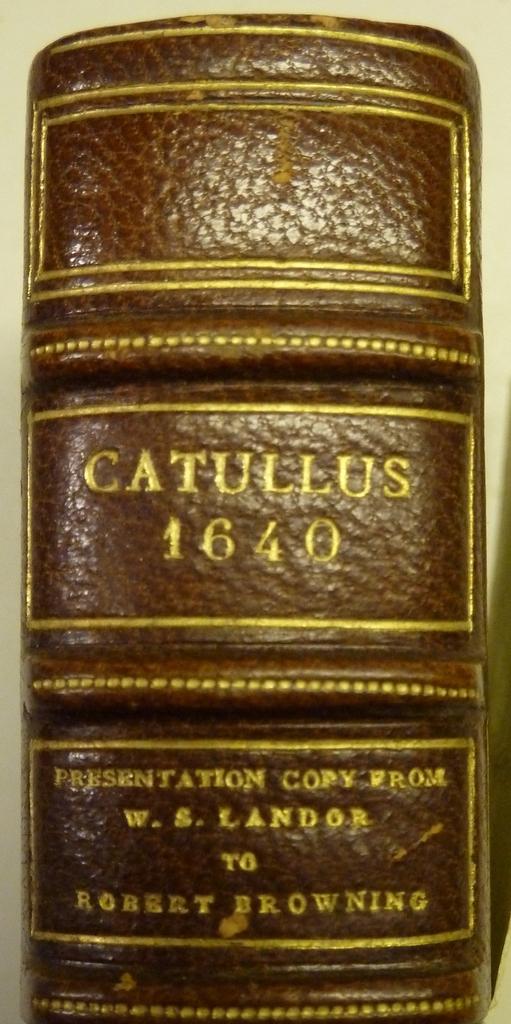What's the name of this book?
Keep it short and to the point. Catullus. What year is on this book?
Your response must be concise. 1640. 